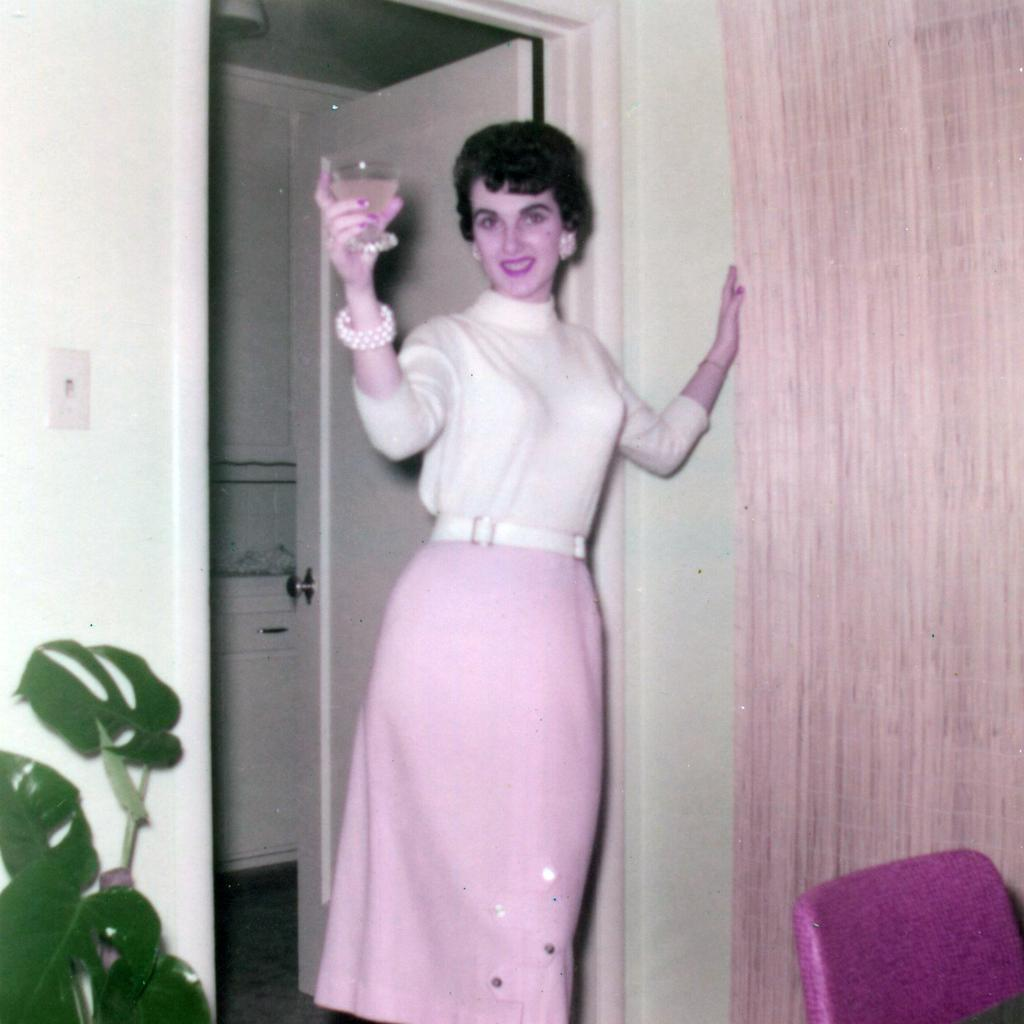What is the main subject of the image? There is a woman in the image. What is the woman doing in the image? The woman is standing and smiling. What is the woman holding in the image? The woman is holding a wine glass. Can you describe the setting of the image? There is a chair, a curtain, a door, and a house plant in the image. What type of polish is the woman applying to her nails in the image? There is no indication in the image that the woman is applying any polish to her nails. Can you see any trains in the image? There are no trains present in the image. 